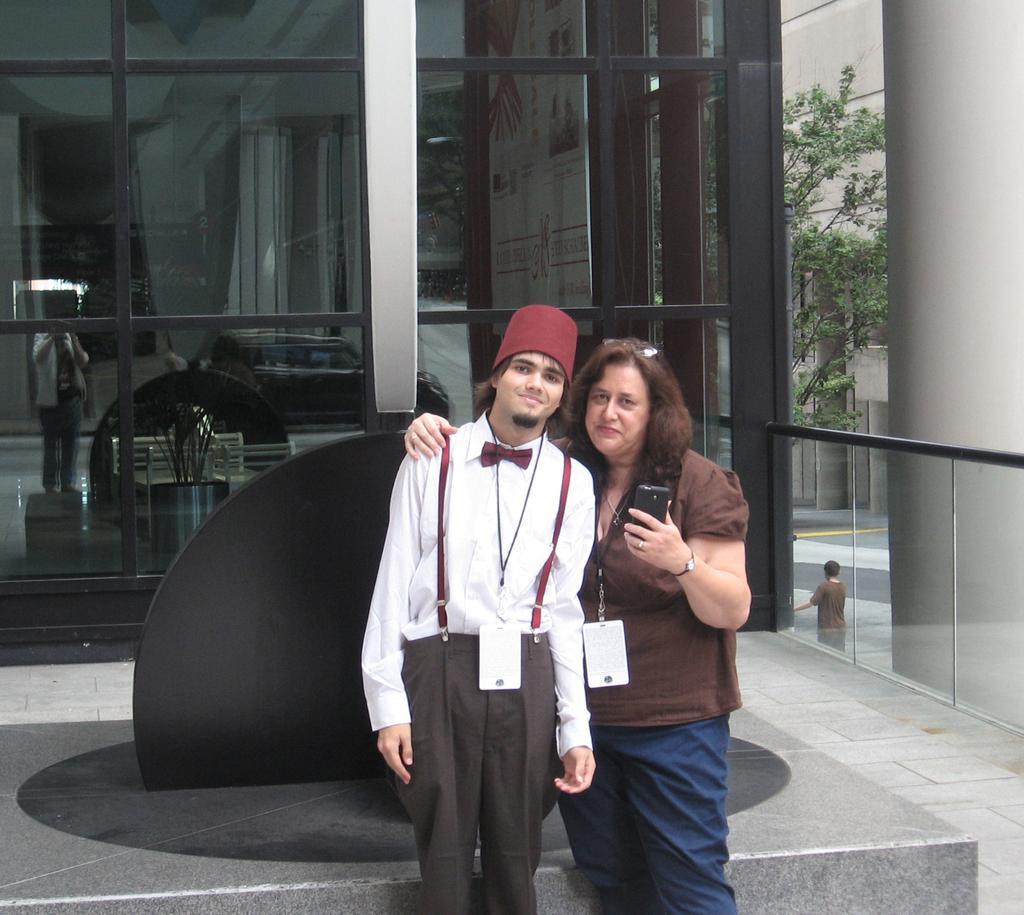How would you summarize this image in a sentence or two? In this image in the foreground there are two persons who are standing, and one person is holding a mobile. And in the background there is a building, and on the right side there are some trees and one person is standing. At the bottom there is a walkway. 